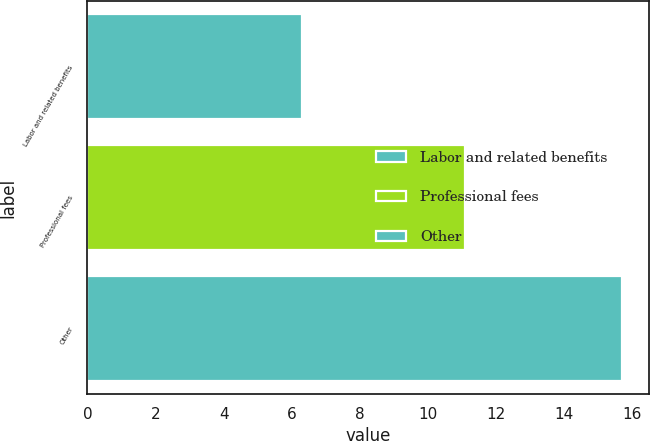<chart> <loc_0><loc_0><loc_500><loc_500><bar_chart><fcel>Labor and related benefits<fcel>Professional fees<fcel>Other<nl><fcel>6.3<fcel>11.1<fcel>15.7<nl></chart> 